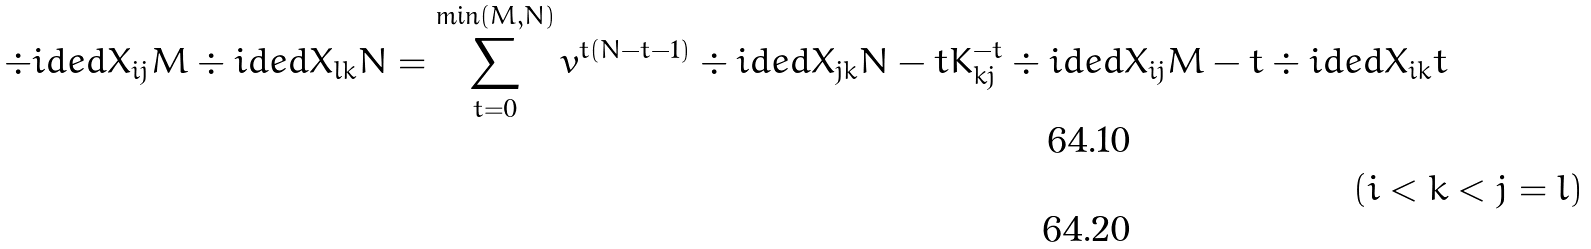Convert formula to latex. <formula><loc_0><loc_0><loc_500><loc_500>\div i d e d { X _ { i j } } { M } \div i d e d { X _ { l k } } { N } = \sum _ { t = 0 } ^ { \min ( M , N ) } v ^ { t ( N - t - 1 ) } \div i d e d { X _ { j k } } { N - t } K _ { k j } ^ { - t } \div i d e d { X _ { i j } } { M - t } \div i d e d { X _ { i k } } { t } & \\ ( i < k & < j = l )</formula> 